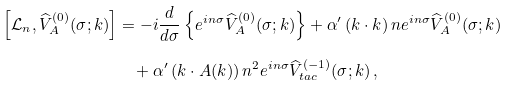<formula> <loc_0><loc_0><loc_500><loc_500>\, \left [ \mathcal { L } _ { n } , \widehat { V } ^ { ( 0 ) } _ { A } ( \sigma ; k ) \right ] & = - i \frac { d } { d \sigma } \left \{ e ^ { i n \sigma } \widehat { V } _ { A } ^ { ( 0 ) } ( \sigma ; k ) \right \} + \alpha ^ { \prime } \left ( k \cdot { k } \right ) n e ^ { i n \sigma } \widehat { V } _ { A } ^ { ( 0 ) } ( \sigma ; k ) \\ & \quad + \alpha ^ { \prime } \left ( k \cdot { A } ( k ) \right ) n ^ { 2 } e ^ { i n \sigma } \widehat { V } _ { t a c } ^ { ( - 1 ) } ( \sigma ; k ) \, ,</formula> 